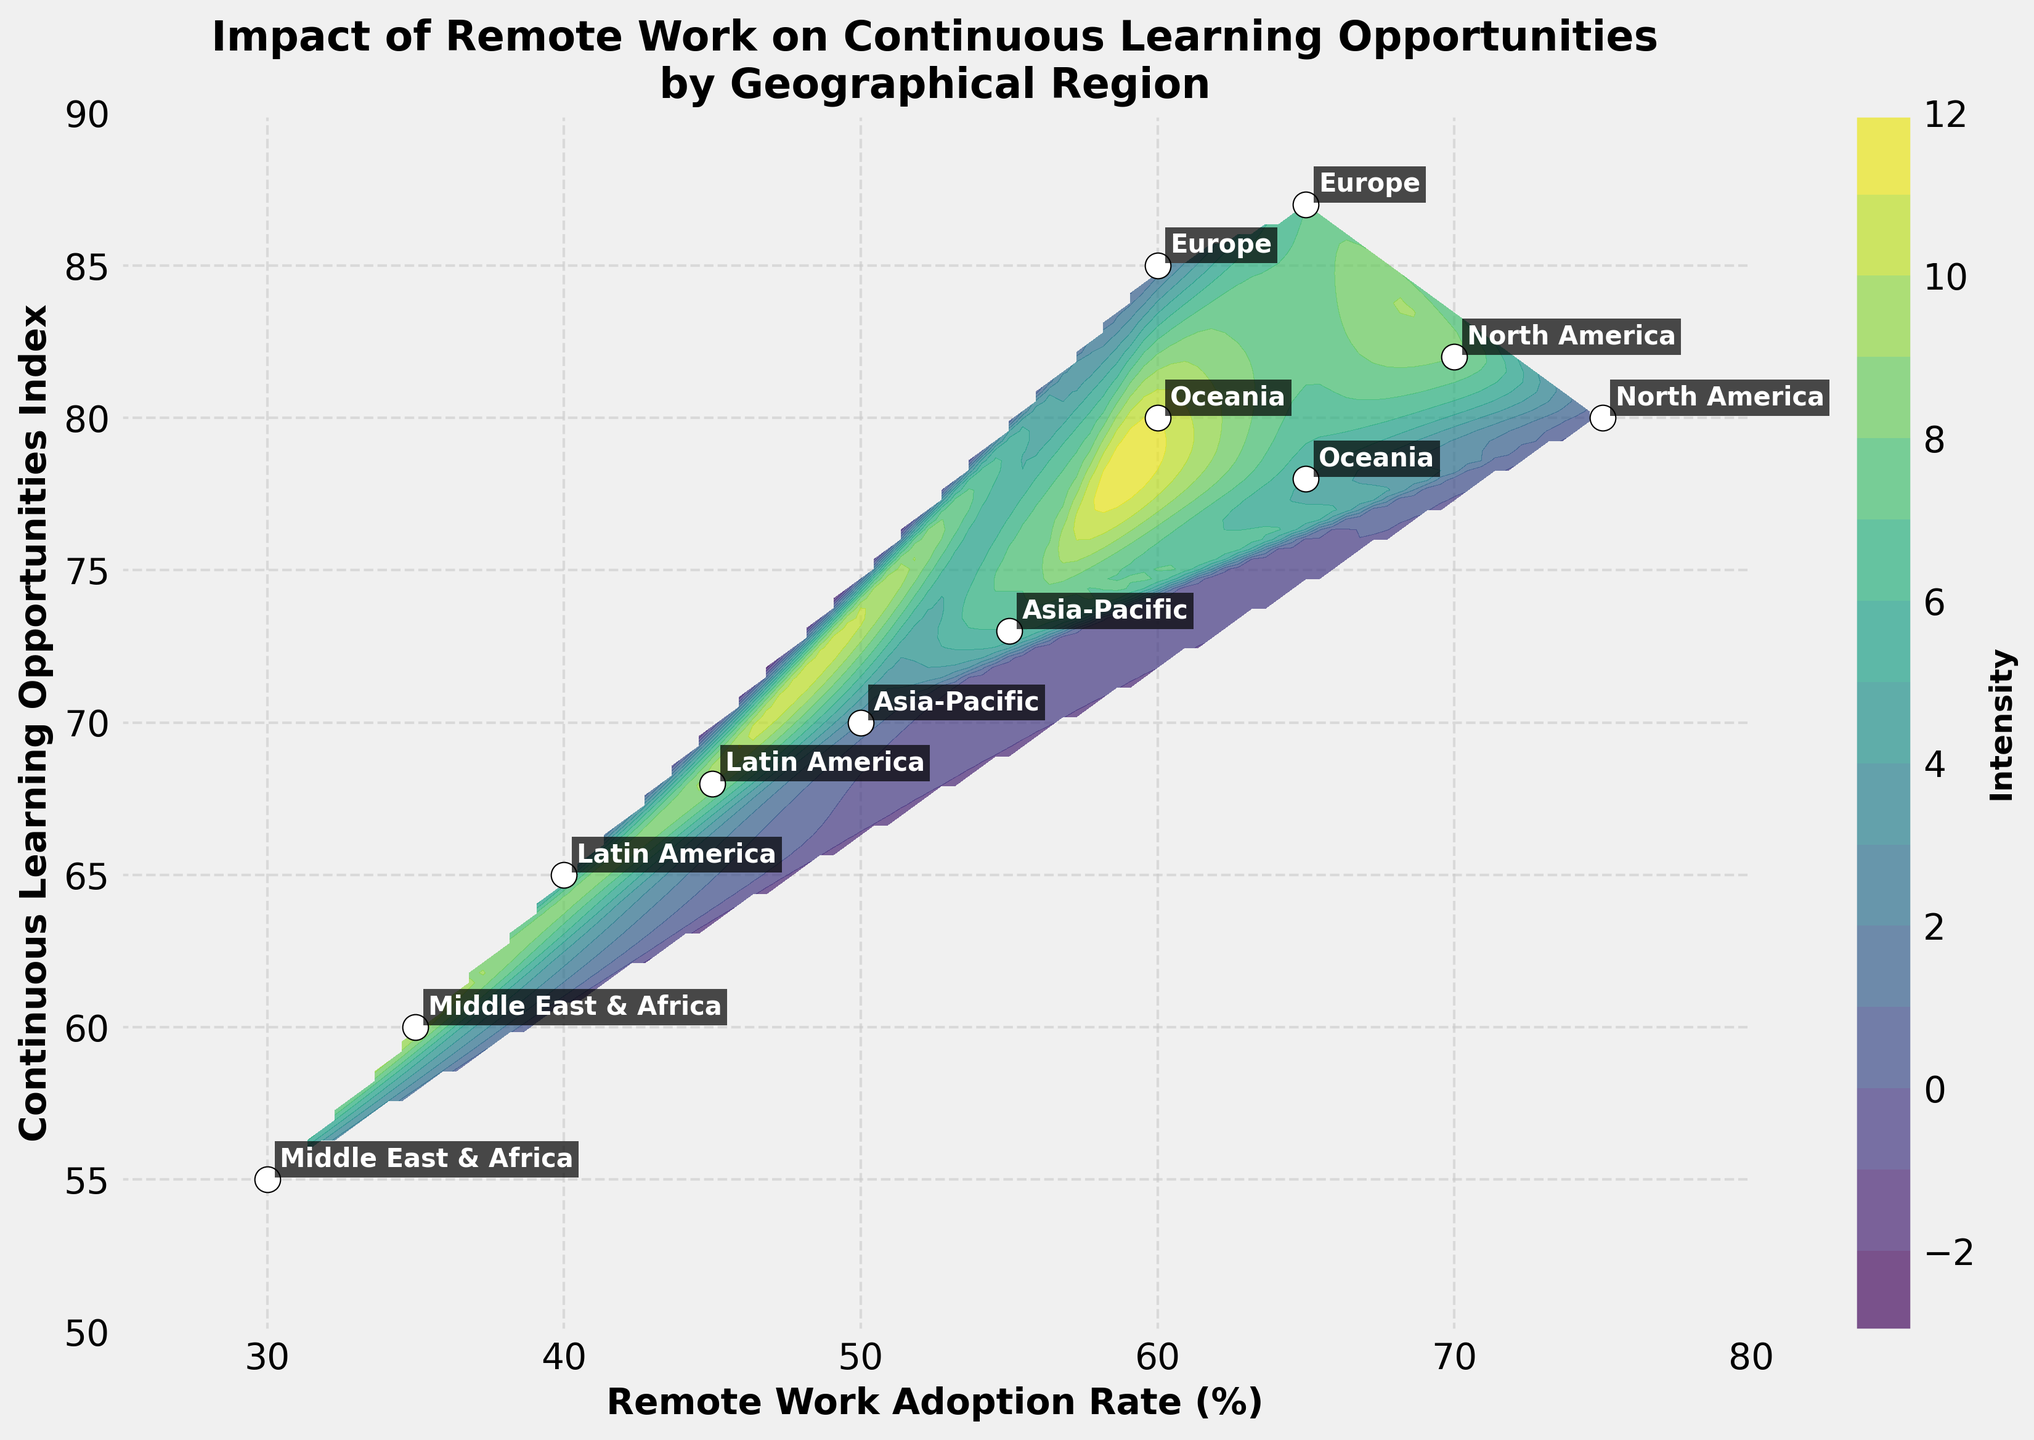Which region has the highest Continuous Learning Opportunities Index? The region with the highest value on the y-axis identifies the highest index. Europe has the highest index value of 87.
Answer: Europe What is the range of the Continuous Learning Opportunities Index in the figure? The minimum value on the y-axis is 50, and the maximum value is 90. Thus, the range is 90 - 50 = 40.
Answer: 40 Compare the Remote Work Adoption Rate (%) between North America and Asia-Pacific. Which region has a higher rate? Compare the x-axis values of the respective regions: North America has values of 75% and 70%, and Asia-Pacific has values of 50% and 55%. North America consistently has higher values.
Answer: North America What is the average Continuous Learning Opportunities Index for Latin America? Latin America has two data points: 65 and 68. Calculate the average by adding these values and dividing by 2. (65 + 68) / 2 = 66.5
Answer: 66.5 Identify the region with the lowest Continuous Learning Opportunities Index and state its Remote Work Adoption Rate. Identify the lowest point on the y-axis, which is 55 for the Middle East & Africa. Check the x-axis for its corresponding Remote Work Adoption Rate, which is 30%.
Answer: Middle East & Africa, 30% Which regions lie in the top right quadrant of the plot? The top right quadrant includes regions with high Remote Work Adoption Rates (%) and high Continuous Learning Opportunities Indexes. North America and Europe have these characteristics.
Answer: North America, Europe What is the difference in Remote Work Adoption Rate (%) between Oceania and the Middle East & Africa? Identify the corresponding values for Oceania (65%, 60%) and the Middle East & Africa (30%, 35%). The differences are 65 - 30 = 35 and 60 - 35 = 25.
Answer: 35, 25 Which region has both relatively low Remote Work Adoption Rate (%) and Continuous Learning Opportunities Index? Look for points with low x and y values. The Middle East & Africa, with Remote Work Adoption Rates of 30% and 35% and Continuous Learning Opportunities Indexes of 55 and 60, fits this description.
Answer: Middle East & Africa 